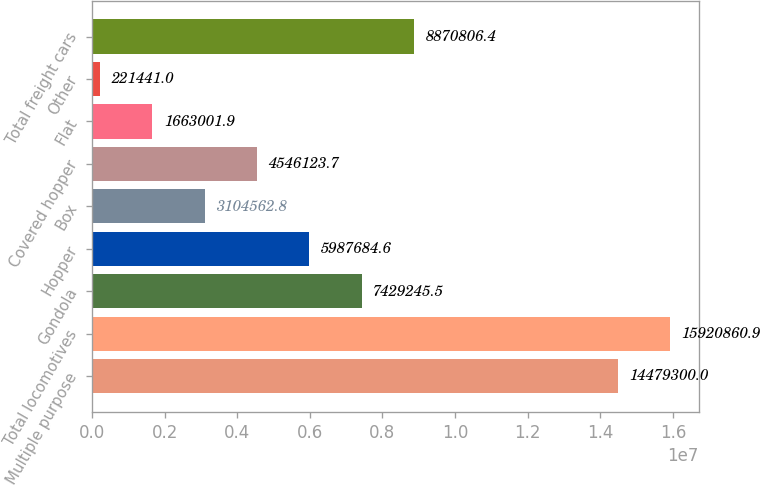<chart> <loc_0><loc_0><loc_500><loc_500><bar_chart><fcel>Multiple purpose<fcel>Total locomotives<fcel>Gondola<fcel>Hopper<fcel>Box<fcel>Covered hopper<fcel>Flat<fcel>Other<fcel>Total freight cars<nl><fcel>1.44793e+07<fcel>1.59209e+07<fcel>7.42925e+06<fcel>5.98768e+06<fcel>3.10456e+06<fcel>4.54612e+06<fcel>1.663e+06<fcel>221441<fcel>8.87081e+06<nl></chart> 